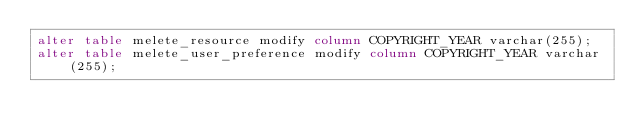Convert code to text. <code><loc_0><loc_0><loc_500><loc_500><_SQL_>alter table melete_resource modify column COPYRIGHT_YEAR varchar(255);
alter table melete_user_preference modify column COPYRIGHT_YEAR varchar(255);
</code> 